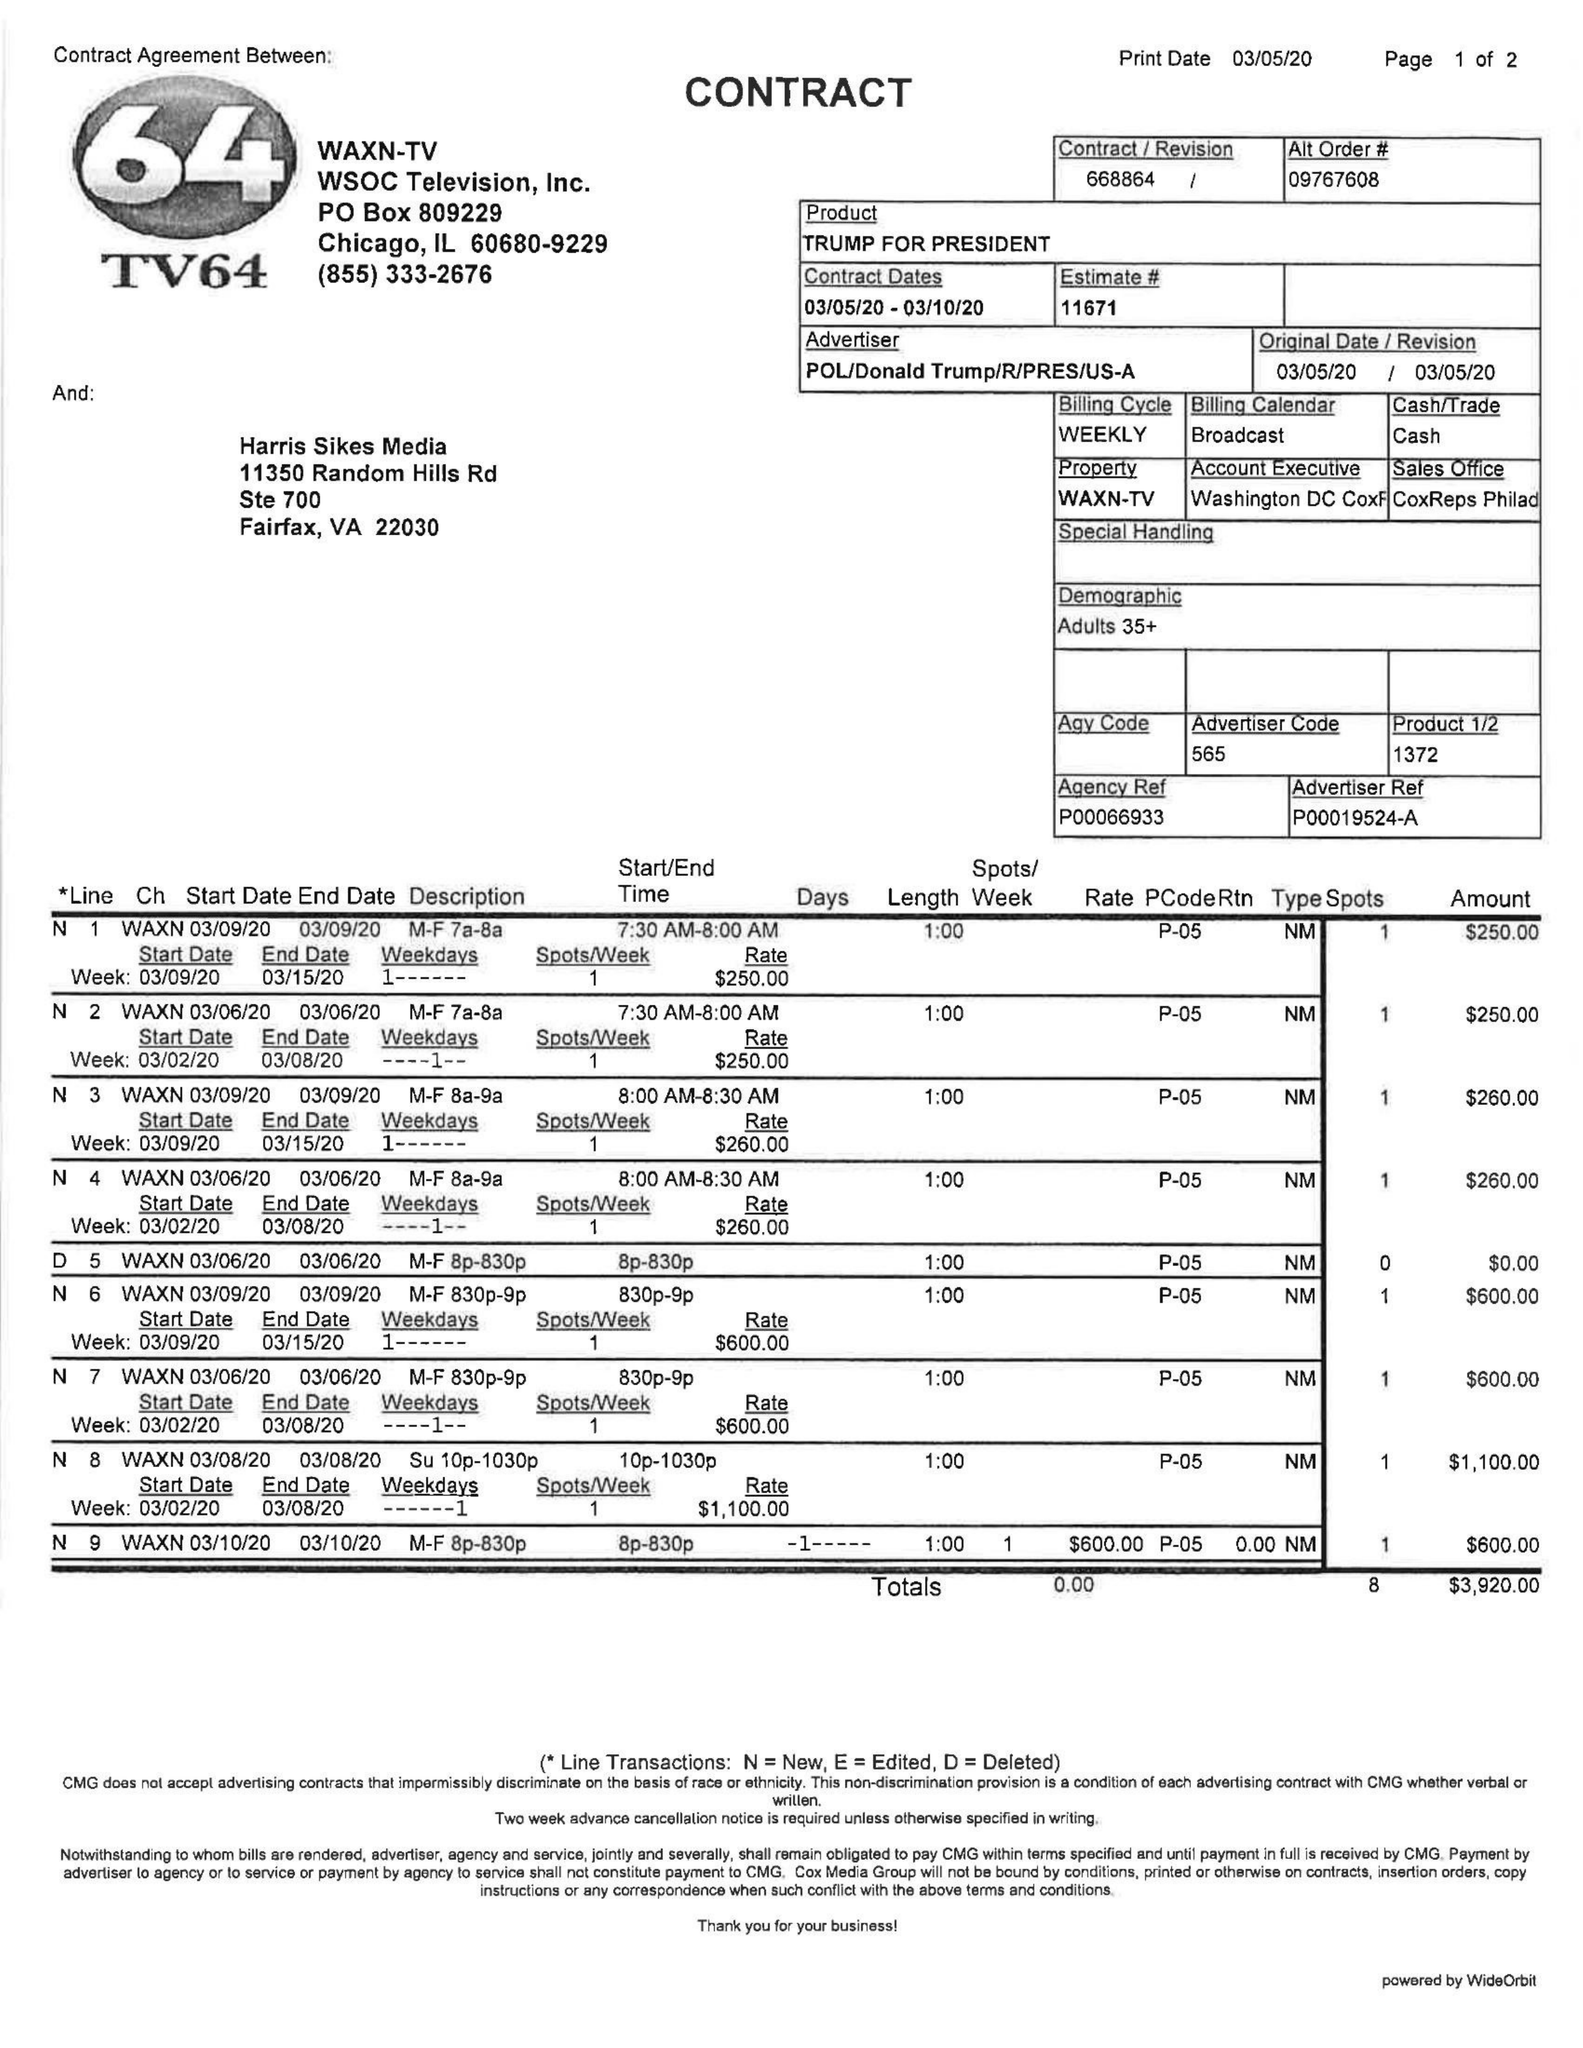What is the value for the contract_num?
Answer the question using a single word or phrase. 668864 